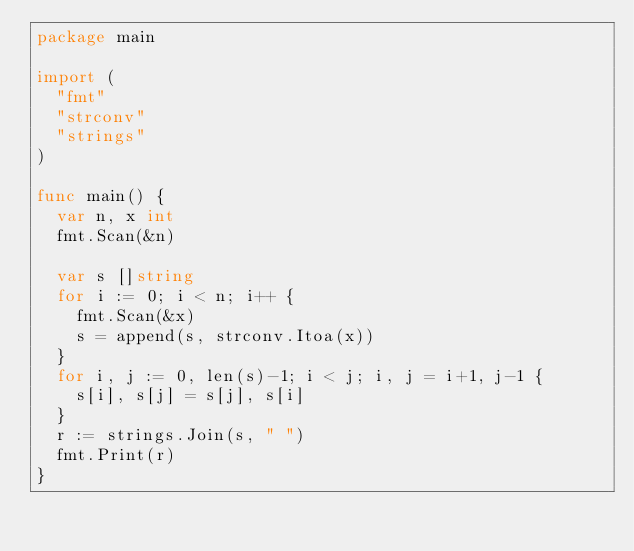<code> <loc_0><loc_0><loc_500><loc_500><_Go_>package main

import (
	"fmt"
	"strconv"
	"strings"
)

func main() {
	var n, x int
	fmt.Scan(&n)

	var s []string
	for i := 0; i < n; i++ {
		fmt.Scan(&x)
		s = append(s, strconv.Itoa(x))
	}
	for i, j := 0, len(s)-1; i < j; i, j = i+1, j-1 {
		s[i], s[j] = s[j], s[i]
	}
	r := strings.Join(s, " ")
	fmt.Print(r)
}</code> 